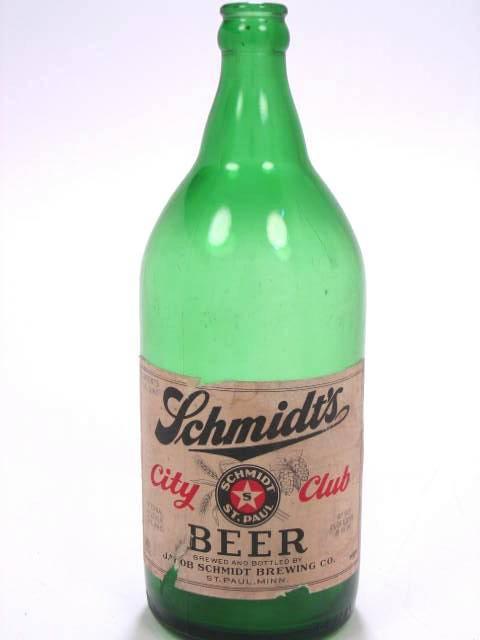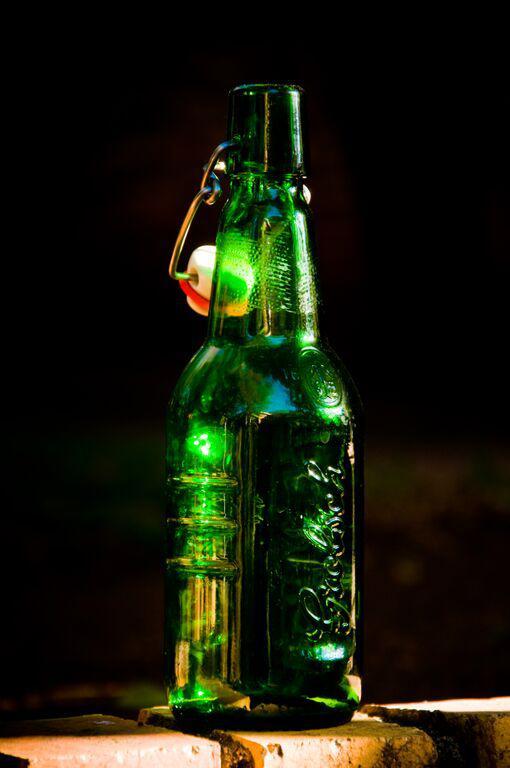The first image is the image on the left, the second image is the image on the right. Evaluate the accuracy of this statement regarding the images: "Three identical green bottles are standing in a row.". Is it true? Answer yes or no. No. The first image is the image on the left, the second image is the image on the right. Assess this claim about the two images: "there are six bottles". Correct or not? Answer yes or no. No. 